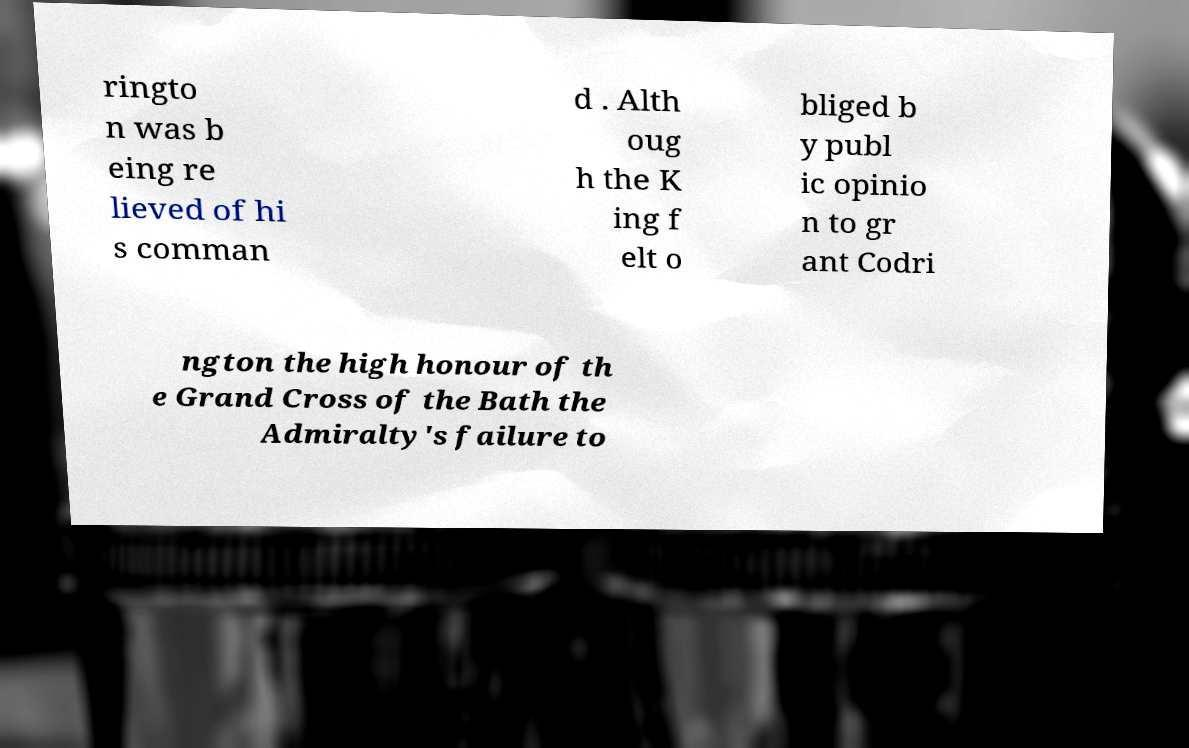Could you assist in decoding the text presented in this image and type it out clearly? ringto n was b eing re lieved of hi s comman d . Alth oug h the K ing f elt o bliged b y publ ic opinio n to gr ant Codri ngton the high honour of th e Grand Cross of the Bath the Admiralty's failure to 